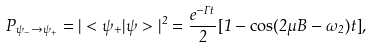<formula> <loc_0><loc_0><loc_500><loc_500>P _ { \psi _ { - } \rightarrow \psi _ { + } } = | < \psi _ { + } | \psi > | ^ { 2 } = \frac { e ^ { - \Gamma t } } { 2 } [ 1 - \cos ( 2 \mu B - \omega _ { 2 } ) t ] { , }</formula> 